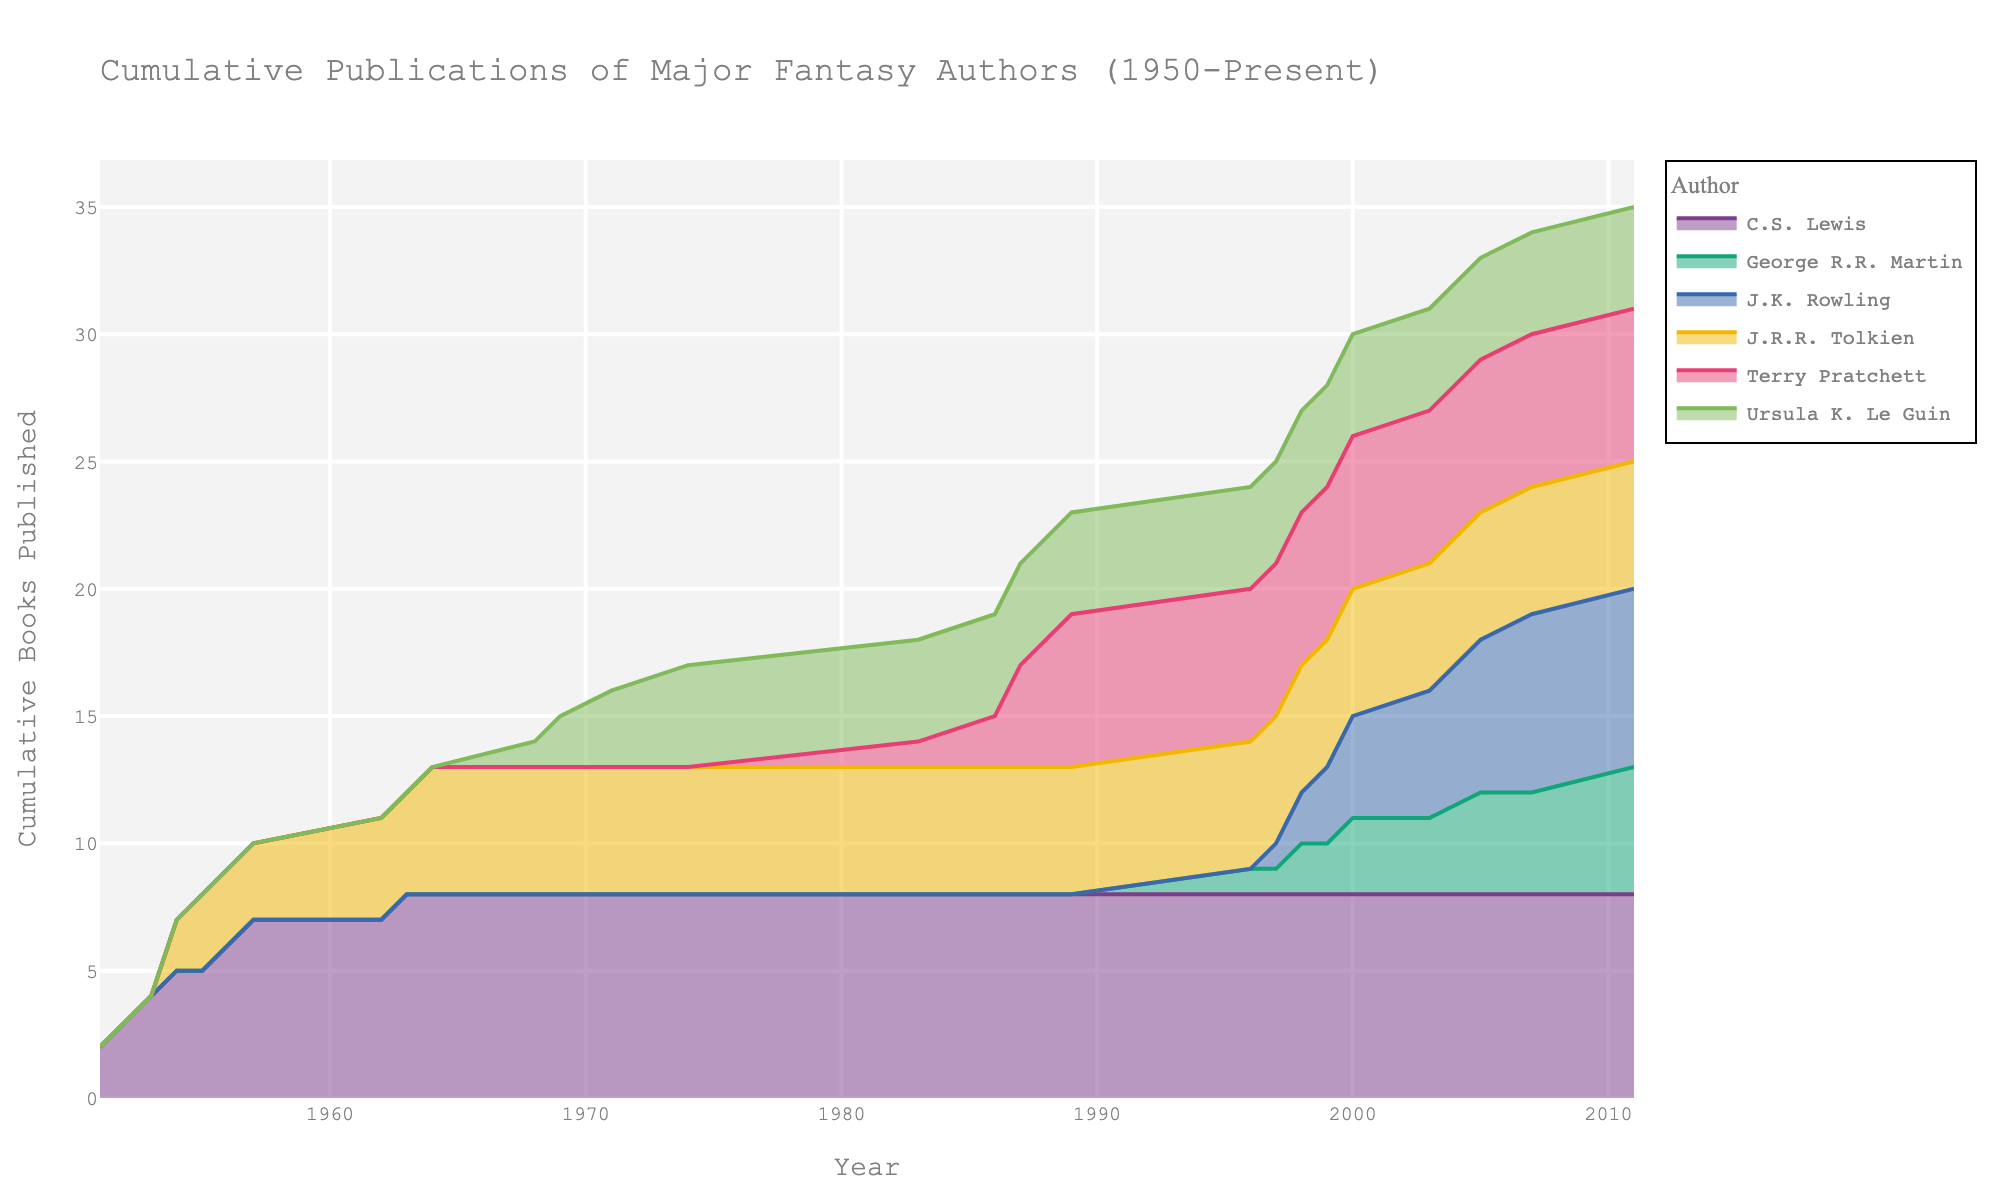What is the title of the area chart? The title of the area chart is usually located at the top center and summarizes the content.
Answer: Cumulative Publications of Major Fantasy Authors (1950-Present) Which author has the highest peak in cumulative books published? By looking at the highest point of each author's area on the chart, we can easily identify which author's maximum value is the greatest.
Answer: J.K. Rowling In which year did George R.R. Martin first start publishing books according to the chart? We identify George R.R. Martin's first year of publication by looking at the starting point of his area.
Answer: 1996 How many books had J.R.R. Tolkien published by 1965 according to the cumulative data? J.R.R. Tolkien's cumulative data in 1965 can be found by locating the year on the x-axis and checking the corresponding value under his name.
Answer: 5 Whose cumulative publications increased the most between 2000 and 2007? Find the authors' publication values at 2000 and 2007 and calculate the difference for each.
Answer: J.K. Rowling What is the cumulative number of books published by all authors by 1990? Sum the cumulative publications of all authors at the year 1990 by adding the final values of each author's area.
Answer: 12 Which author continued to publish books at a consistent rate after their initial publication year? We observe which author's area grows steadily without significant jumps or pauses.
Answer: Terry Pratchett After 1965, which author did not publish any more books according to the chart? Look for authors with a flat cumulative line after 1965, indicating no additional publications.
Answer: J.R.R. Tolkien Between which years did Terry Pratchett publish his first set of books, according to the chart? Identify the first noticeable increase in Terry Pratchett's cumulative publications by observing the starting and ending points of initial growth.
Answer: 1983 to 1989 